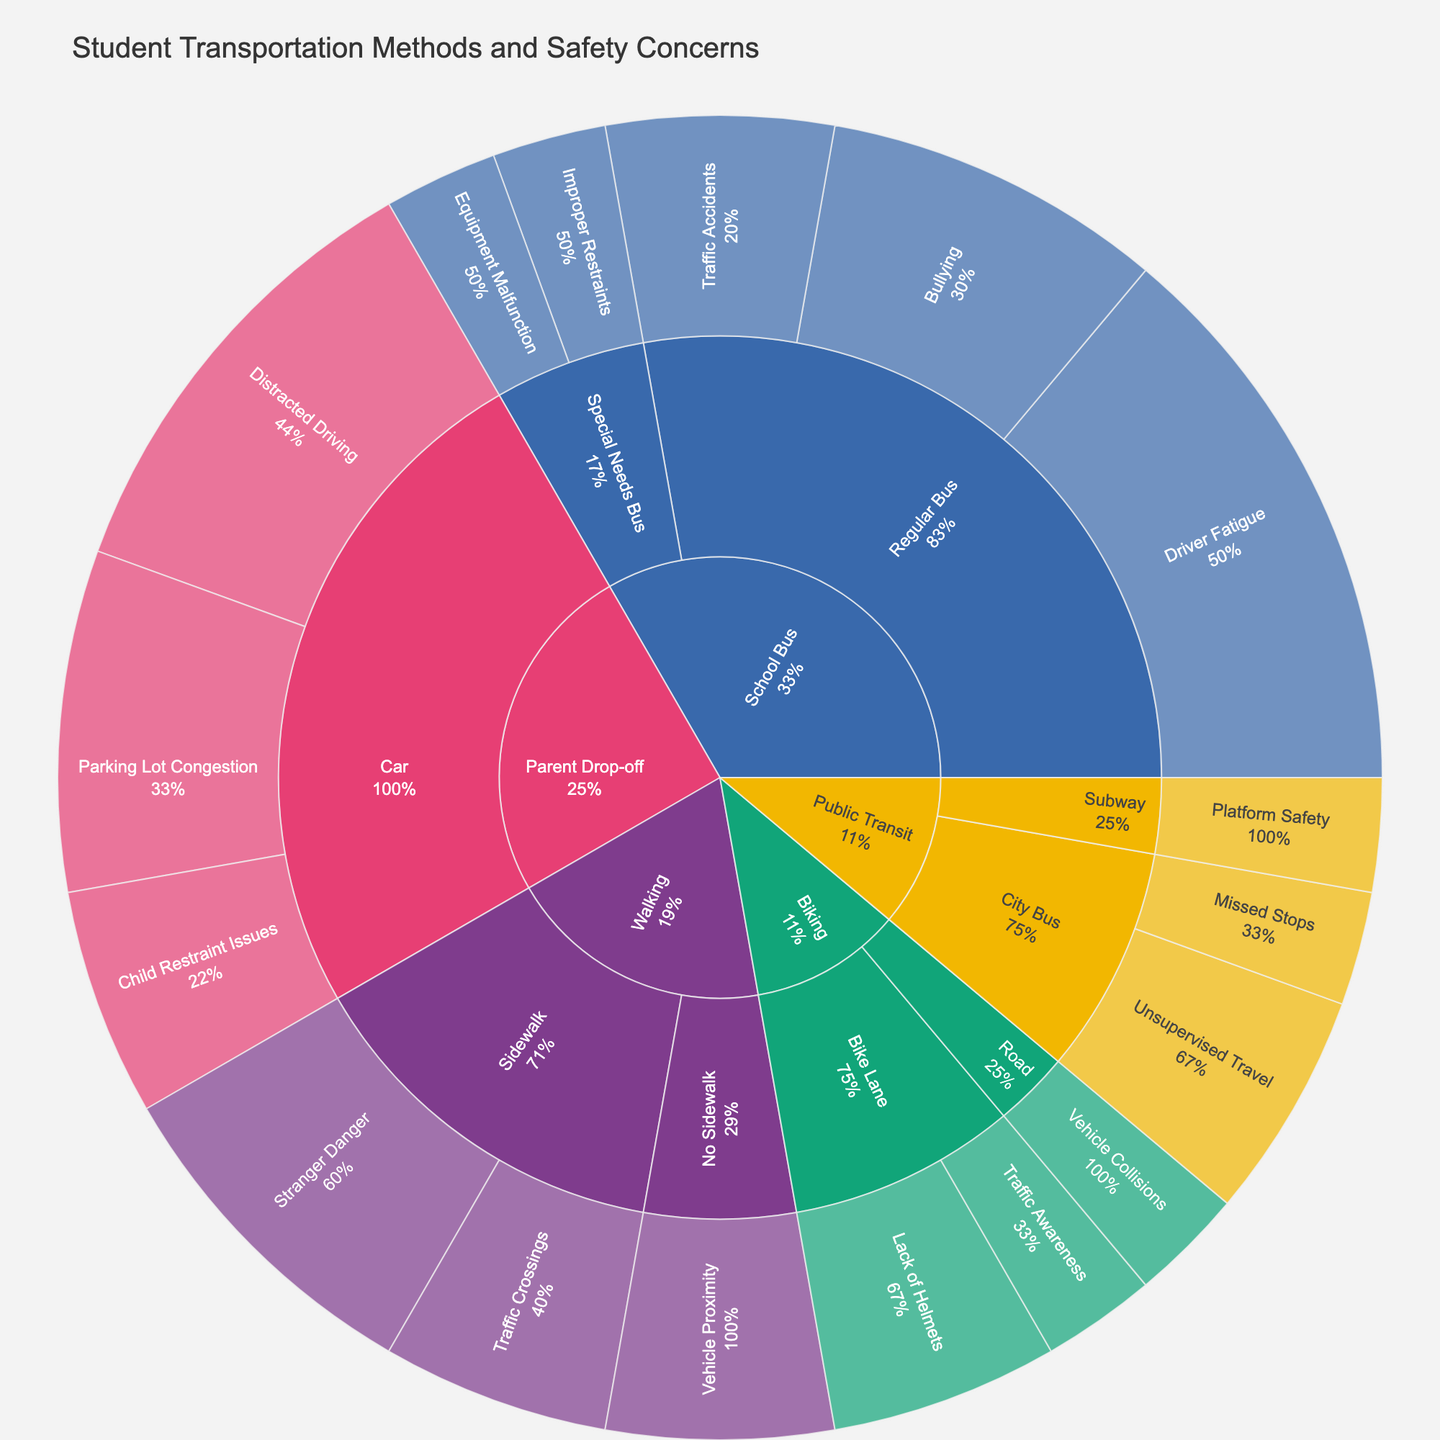What is the title of the figure? The title of the figure is displayed at the top of the plot. It summarizes the content shown.
Answer: Student Transportation Methods and Safety Concerns Which transportation method has the highest total percentage of safety concerns? By examining the outermost arcs of the sunburst, we can sum the percentages of safety concerns for each transportation method. School Bus has the highest total.
Answer: School Bus What are the two safety concerns associated with the highest percentages under Parent Drop-off method? For the Parent Drop-off method, observe the outermost arcs and their associated percentages. The two highest are Distracted Driving and Parking Lot Congestion.
Answer: Distracted Driving and Parking Lot Congestion How does the total percentage of safety concerns for Walking compare to that for Biking? Sum the percentages for safety concerns under Walking (3 + 2 + 2 = 7) and compare it with Biking (2 + 1 + 1 = 4).
Answer: Walking has a higher total percentage Which specific safety concern has the highest percentage across all transportation methods? By exploring the outermost arcs, we see that Driver Fatigue under Regular Bus has the highest percentage.
Answer: Driver Fatigue What is the combined percentage of safety concerns related to vehicle proximity? Add the percentages for Traffic Accidents (Regular Bus - 2) and Vehicle Proximity (No Sidewalk - 2).
Answer: 4 Which combination of transportation method and safety concern has the lowest percentage? The lowest percentage combination is under Special Needs Bus with Improper Restraints and Equipment Malfunction, each at 1%.
Answer: Special Needs Bus with Improper Restraints and Equipment Malfunction What is the percentage of safety concerns related to sidewalk issues for walking? Sum the percentages listed under Walking that involve sidewalks: Stranger Danger (3) and Traffic Crossings (2).
Answer: 5 